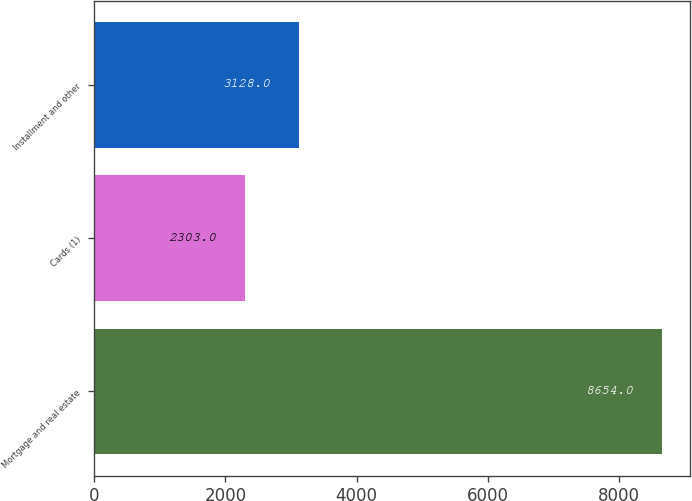Convert chart to OTSL. <chart><loc_0><loc_0><loc_500><loc_500><bar_chart><fcel>Mortgage and real estate<fcel>Cards (1)<fcel>Installment and other<nl><fcel>8654<fcel>2303<fcel>3128<nl></chart> 